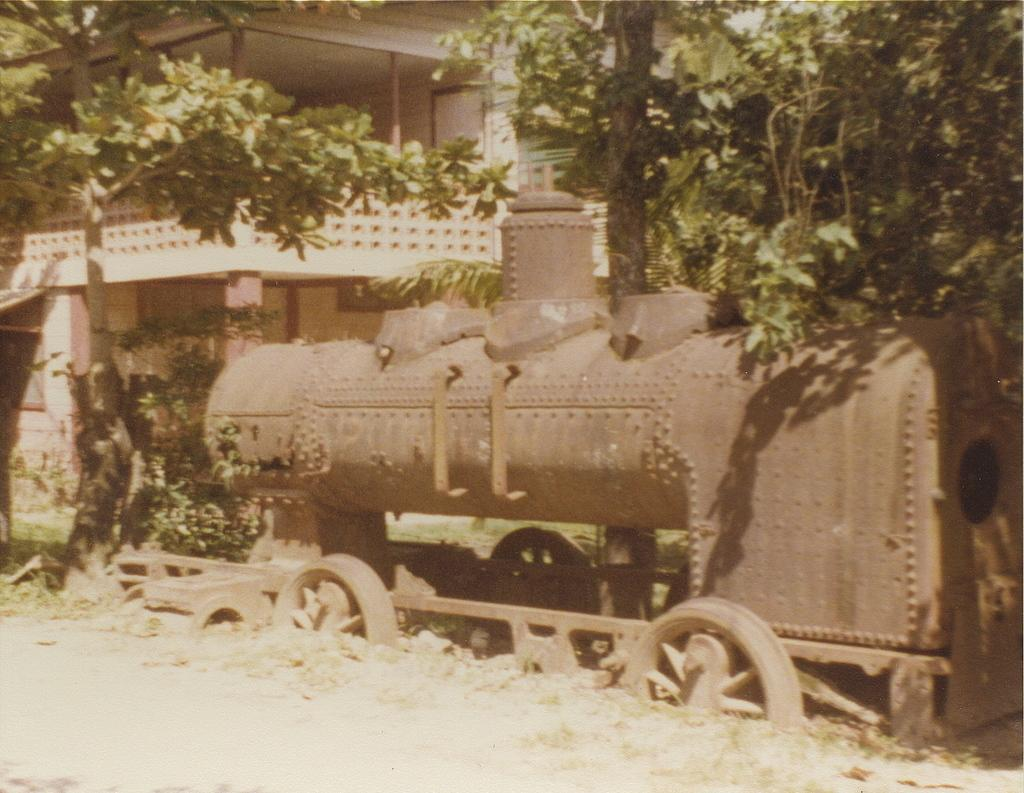What is the main subject in the image? There is a vehicle in the image. What can be seen in the image besides the vehicle? There are trees in the image. What is visible in the background of the image? There is a building in the background of the image. What type of writing can be seen on the trees in the image? There is no writing visible on the trees in the image. 